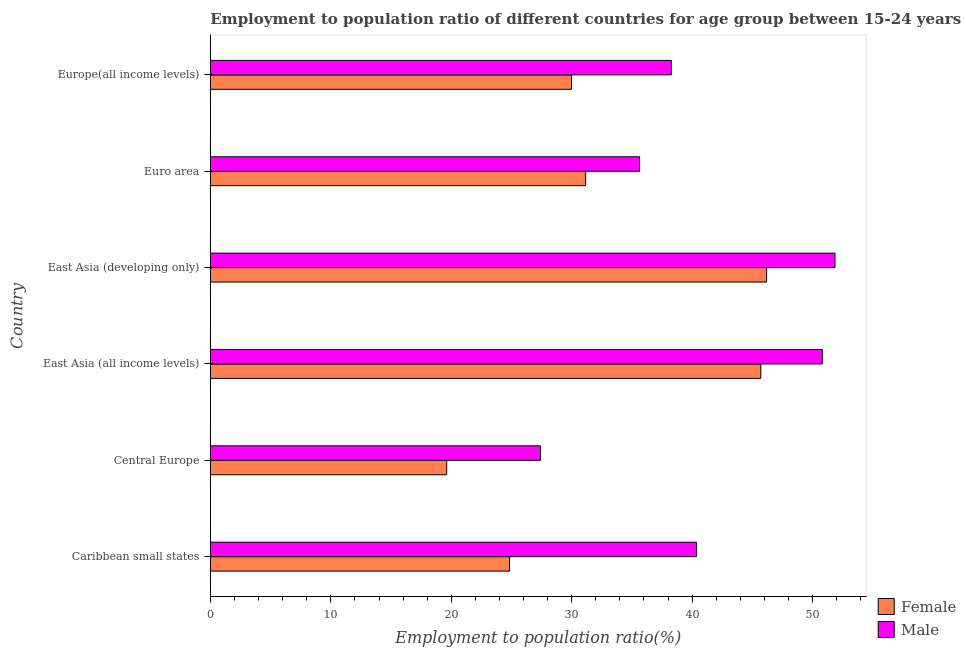How many bars are there on the 2nd tick from the top?
Provide a succinct answer. 2. What is the label of the 4th group of bars from the top?
Provide a short and direct response. East Asia (all income levels). What is the employment to population ratio(male) in Caribbean small states?
Provide a short and direct response. 40.37. Across all countries, what is the maximum employment to population ratio(male)?
Keep it short and to the point. 51.87. Across all countries, what is the minimum employment to population ratio(male)?
Offer a terse response. 27.41. In which country was the employment to population ratio(female) maximum?
Your response must be concise. East Asia (developing only). In which country was the employment to population ratio(male) minimum?
Ensure brevity in your answer.  Central Europe. What is the total employment to population ratio(male) in the graph?
Your response must be concise. 244.37. What is the difference between the employment to population ratio(male) in Central Europe and that in East Asia (developing only)?
Provide a succinct answer. -24.46. What is the difference between the employment to population ratio(male) in Euro area and the employment to population ratio(female) in East Asia (developing only)?
Ensure brevity in your answer.  -10.55. What is the average employment to population ratio(female) per country?
Your answer should be compact. 32.91. What is the difference between the employment to population ratio(male) and employment to population ratio(female) in Europe(all income levels)?
Offer a terse response. 8.29. In how many countries, is the employment to population ratio(male) greater than 20 %?
Ensure brevity in your answer.  6. What is the ratio of the employment to population ratio(male) in Central Europe to that in Europe(all income levels)?
Your answer should be compact. 0.72. What is the difference between the highest and the second highest employment to population ratio(female)?
Offer a terse response. 0.48. What is the difference between the highest and the lowest employment to population ratio(male)?
Give a very brief answer. 24.46. Is the sum of the employment to population ratio(female) in East Asia (all income levels) and Euro area greater than the maximum employment to population ratio(male) across all countries?
Provide a succinct answer. Yes. How many countries are there in the graph?
Provide a short and direct response. 6. Are the values on the major ticks of X-axis written in scientific E-notation?
Your answer should be very brief. No. Does the graph contain any zero values?
Make the answer very short. No. Does the graph contain grids?
Your answer should be very brief. No. Where does the legend appear in the graph?
Give a very brief answer. Bottom right. How are the legend labels stacked?
Your answer should be very brief. Vertical. What is the title of the graph?
Your answer should be very brief. Employment to population ratio of different countries for age group between 15-24 years. Does "GDP at market prices" appear as one of the legend labels in the graph?
Your answer should be compact. No. What is the Employment to population ratio(%) in Female in Caribbean small states?
Your answer should be very brief. 24.84. What is the Employment to population ratio(%) of Male in Caribbean small states?
Your answer should be very brief. 40.37. What is the Employment to population ratio(%) in Female in Central Europe?
Provide a short and direct response. 19.62. What is the Employment to population ratio(%) of Male in Central Europe?
Your answer should be compact. 27.41. What is the Employment to population ratio(%) of Female in East Asia (all income levels)?
Offer a terse response. 45.71. What is the Employment to population ratio(%) of Male in East Asia (all income levels)?
Offer a terse response. 50.81. What is the Employment to population ratio(%) of Female in East Asia (developing only)?
Ensure brevity in your answer.  46.19. What is the Employment to population ratio(%) of Male in East Asia (developing only)?
Give a very brief answer. 51.87. What is the Employment to population ratio(%) of Female in Euro area?
Provide a short and direct response. 31.16. What is the Employment to population ratio(%) of Male in Euro area?
Provide a succinct answer. 35.64. What is the Employment to population ratio(%) in Female in Europe(all income levels)?
Keep it short and to the point. 29.98. What is the Employment to population ratio(%) of Male in Europe(all income levels)?
Offer a very short reply. 38.28. Across all countries, what is the maximum Employment to population ratio(%) in Female?
Ensure brevity in your answer.  46.19. Across all countries, what is the maximum Employment to population ratio(%) of Male?
Make the answer very short. 51.87. Across all countries, what is the minimum Employment to population ratio(%) of Female?
Your response must be concise. 19.62. Across all countries, what is the minimum Employment to population ratio(%) of Male?
Offer a very short reply. 27.41. What is the total Employment to population ratio(%) of Female in the graph?
Keep it short and to the point. 197.49. What is the total Employment to population ratio(%) of Male in the graph?
Offer a very short reply. 244.37. What is the difference between the Employment to population ratio(%) of Female in Caribbean small states and that in Central Europe?
Offer a terse response. 5.22. What is the difference between the Employment to population ratio(%) in Male in Caribbean small states and that in Central Europe?
Offer a very short reply. 12.97. What is the difference between the Employment to population ratio(%) in Female in Caribbean small states and that in East Asia (all income levels)?
Your response must be concise. -20.87. What is the difference between the Employment to population ratio(%) of Male in Caribbean small states and that in East Asia (all income levels)?
Offer a terse response. -10.44. What is the difference between the Employment to population ratio(%) in Female in Caribbean small states and that in East Asia (developing only)?
Keep it short and to the point. -21.35. What is the difference between the Employment to population ratio(%) in Male in Caribbean small states and that in East Asia (developing only)?
Ensure brevity in your answer.  -11.49. What is the difference between the Employment to population ratio(%) of Female in Caribbean small states and that in Euro area?
Your response must be concise. -6.32. What is the difference between the Employment to population ratio(%) in Male in Caribbean small states and that in Euro area?
Make the answer very short. 4.74. What is the difference between the Employment to population ratio(%) of Female in Caribbean small states and that in Europe(all income levels)?
Your answer should be very brief. -5.15. What is the difference between the Employment to population ratio(%) in Male in Caribbean small states and that in Europe(all income levels)?
Provide a succinct answer. 2.1. What is the difference between the Employment to population ratio(%) of Female in Central Europe and that in East Asia (all income levels)?
Keep it short and to the point. -26.09. What is the difference between the Employment to population ratio(%) of Male in Central Europe and that in East Asia (all income levels)?
Give a very brief answer. -23.41. What is the difference between the Employment to population ratio(%) of Female in Central Europe and that in East Asia (developing only)?
Offer a very short reply. -26.57. What is the difference between the Employment to population ratio(%) of Male in Central Europe and that in East Asia (developing only)?
Your answer should be compact. -24.46. What is the difference between the Employment to population ratio(%) in Female in Central Europe and that in Euro area?
Provide a succinct answer. -11.54. What is the difference between the Employment to population ratio(%) of Male in Central Europe and that in Euro area?
Give a very brief answer. -8.23. What is the difference between the Employment to population ratio(%) of Female in Central Europe and that in Europe(all income levels)?
Your answer should be very brief. -10.36. What is the difference between the Employment to population ratio(%) in Male in Central Europe and that in Europe(all income levels)?
Your response must be concise. -10.87. What is the difference between the Employment to population ratio(%) in Female in East Asia (all income levels) and that in East Asia (developing only)?
Offer a terse response. -0.48. What is the difference between the Employment to population ratio(%) in Male in East Asia (all income levels) and that in East Asia (developing only)?
Ensure brevity in your answer.  -1.06. What is the difference between the Employment to population ratio(%) in Female in East Asia (all income levels) and that in Euro area?
Make the answer very short. 14.55. What is the difference between the Employment to population ratio(%) of Male in East Asia (all income levels) and that in Euro area?
Your response must be concise. 15.17. What is the difference between the Employment to population ratio(%) of Female in East Asia (all income levels) and that in Europe(all income levels)?
Your response must be concise. 15.73. What is the difference between the Employment to population ratio(%) in Male in East Asia (all income levels) and that in Europe(all income levels)?
Your answer should be very brief. 12.53. What is the difference between the Employment to population ratio(%) of Female in East Asia (developing only) and that in Euro area?
Your answer should be very brief. 15.03. What is the difference between the Employment to population ratio(%) of Male in East Asia (developing only) and that in Euro area?
Your answer should be compact. 16.23. What is the difference between the Employment to population ratio(%) in Female in East Asia (developing only) and that in Europe(all income levels)?
Provide a succinct answer. 16.2. What is the difference between the Employment to population ratio(%) in Male in East Asia (developing only) and that in Europe(all income levels)?
Your answer should be compact. 13.59. What is the difference between the Employment to population ratio(%) of Female in Euro area and that in Europe(all income levels)?
Provide a short and direct response. 1.17. What is the difference between the Employment to population ratio(%) in Male in Euro area and that in Europe(all income levels)?
Offer a very short reply. -2.64. What is the difference between the Employment to population ratio(%) of Female in Caribbean small states and the Employment to population ratio(%) of Male in Central Europe?
Your answer should be compact. -2.57. What is the difference between the Employment to population ratio(%) in Female in Caribbean small states and the Employment to population ratio(%) in Male in East Asia (all income levels)?
Ensure brevity in your answer.  -25.97. What is the difference between the Employment to population ratio(%) of Female in Caribbean small states and the Employment to population ratio(%) of Male in East Asia (developing only)?
Your answer should be compact. -27.03. What is the difference between the Employment to population ratio(%) in Female in Caribbean small states and the Employment to population ratio(%) in Male in Euro area?
Ensure brevity in your answer.  -10.8. What is the difference between the Employment to population ratio(%) in Female in Caribbean small states and the Employment to population ratio(%) in Male in Europe(all income levels)?
Provide a succinct answer. -13.44. What is the difference between the Employment to population ratio(%) in Female in Central Europe and the Employment to population ratio(%) in Male in East Asia (all income levels)?
Your answer should be compact. -31.19. What is the difference between the Employment to population ratio(%) in Female in Central Europe and the Employment to population ratio(%) in Male in East Asia (developing only)?
Offer a very short reply. -32.25. What is the difference between the Employment to population ratio(%) in Female in Central Europe and the Employment to population ratio(%) in Male in Euro area?
Your answer should be compact. -16.02. What is the difference between the Employment to population ratio(%) in Female in Central Europe and the Employment to population ratio(%) in Male in Europe(all income levels)?
Give a very brief answer. -18.66. What is the difference between the Employment to population ratio(%) in Female in East Asia (all income levels) and the Employment to population ratio(%) in Male in East Asia (developing only)?
Your answer should be very brief. -6.16. What is the difference between the Employment to population ratio(%) in Female in East Asia (all income levels) and the Employment to population ratio(%) in Male in Euro area?
Give a very brief answer. 10.07. What is the difference between the Employment to population ratio(%) in Female in East Asia (all income levels) and the Employment to population ratio(%) in Male in Europe(all income levels)?
Your response must be concise. 7.43. What is the difference between the Employment to population ratio(%) in Female in East Asia (developing only) and the Employment to population ratio(%) in Male in Euro area?
Your response must be concise. 10.55. What is the difference between the Employment to population ratio(%) of Female in East Asia (developing only) and the Employment to population ratio(%) of Male in Europe(all income levels)?
Offer a very short reply. 7.91. What is the difference between the Employment to population ratio(%) in Female in Euro area and the Employment to population ratio(%) in Male in Europe(all income levels)?
Your answer should be compact. -7.12. What is the average Employment to population ratio(%) in Female per country?
Provide a short and direct response. 32.92. What is the average Employment to population ratio(%) of Male per country?
Offer a very short reply. 40.73. What is the difference between the Employment to population ratio(%) in Female and Employment to population ratio(%) in Male in Caribbean small states?
Provide a succinct answer. -15.54. What is the difference between the Employment to population ratio(%) of Female and Employment to population ratio(%) of Male in Central Europe?
Provide a succinct answer. -7.79. What is the difference between the Employment to population ratio(%) in Female and Employment to population ratio(%) in Male in East Asia (all income levels)?
Make the answer very short. -5.1. What is the difference between the Employment to population ratio(%) of Female and Employment to population ratio(%) of Male in East Asia (developing only)?
Provide a succinct answer. -5.68. What is the difference between the Employment to population ratio(%) of Female and Employment to population ratio(%) of Male in Euro area?
Offer a terse response. -4.48. What is the difference between the Employment to population ratio(%) in Female and Employment to population ratio(%) in Male in Europe(all income levels)?
Your answer should be compact. -8.3. What is the ratio of the Employment to population ratio(%) in Female in Caribbean small states to that in Central Europe?
Your response must be concise. 1.27. What is the ratio of the Employment to population ratio(%) in Male in Caribbean small states to that in Central Europe?
Provide a short and direct response. 1.47. What is the ratio of the Employment to population ratio(%) of Female in Caribbean small states to that in East Asia (all income levels)?
Offer a terse response. 0.54. What is the ratio of the Employment to population ratio(%) in Male in Caribbean small states to that in East Asia (all income levels)?
Offer a terse response. 0.79. What is the ratio of the Employment to population ratio(%) of Female in Caribbean small states to that in East Asia (developing only)?
Ensure brevity in your answer.  0.54. What is the ratio of the Employment to population ratio(%) in Male in Caribbean small states to that in East Asia (developing only)?
Your response must be concise. 0.78. What is the ratio of the Employment to population ratio(%) of Female in Caribbean small states to that in Euro area?
Keep it short and to the point. 0.8. What is the ratio of the Employment to population ratio(%) in Male in Caribbean small states to that in Euro area?
Ensure brevity in your answer.  1.13. What is the ratio of the Employment to population ratio(%) in Female in Caribbean small states to that in Europe(all income levels)?
Your answer should be very brief. 0.83. What is the ratio of the Employment to population ratio(%) in Male in Caribbean small states to that in Europe(all income levels)?
Ensure brevity in your answer.  1.05. What is the ratio of the Employment to population ratio(%) in Female in Central Europe to that in East Asia (all income levels)?
Provide a short and direct response. 0.43. What is the ratio of the Employment to population ratio(%) of Male in Central Europe to that in East Asia (all income levels)?
Ensure brevity in your answer.  0.54. What is the ratio of the Employment to population ratio(%) in Female in Central Europe to that in East Asia (developing only)?
Give a very brief answer. 0.42. What is the ratio of the Employment to population ratio(%) in Male in Central Europe to that in East Asia (developing only)?
Your answer should be compact. 0.53. What is the ratio of the Employment to population ratio(%) of Female in Central Europe to that in Euro area?
Your answer should be very brief. 0.63. What is the ratio of the Employment to population ratio(%) of Male in Central Europe to that in Euro area?
Ensure brevity in your answer.  0.77. What is the ratio of the Employment to population ratio(%) of Female in Central Europe to that in Europe(all income levels)?
Offer a very short reply. 0.65. What is the ratio of the Employment to population ratio(%) of Male in Central Europe to that in Europe(all income levels)?
Your answer should be compact. 0.72. What is the ratio of the Employment to population ratio(%) in Male in East Asia (all income levels) to that in East Asia (developing only)?
Keep it short and to the point. 0.98. What is the ratio of the Employment to population ratio(%) in Female in East Asia (all income levels) to that in Euro area?
Your response must be concise. 1.47. What is the ratio of the Employment to population ratio(%) in Male in East Asia (all income levels) to that in Euro area?
Offer a very short reply. 1.43. What is the ratio of the Employment to population ratio(%) of Female in East Asia (all income levels) to that in Europe(all income levels)?
Provide a short and direct response. 1.52. What is the ratio of the Employment to population ratio(%) in Male in East Asia (all income levels) to that in Europe(all income levels)?
Offer a terse response. 1.33. What is the ratio of the Employment to population ratio(%) in Female in East Asia (developing only) to that in Euro area?
Provide a short and direct response. 1.48. What is the ratio of the Employment to population ratio(%) of Male in East Asia (developing only) to that in Euro area?
Your answer should be very brief. 1.46. What is the ratio of the Employment to population ratio(%) in Female in East Asia (developing only) to that in Europe(all income levels)?
Keep it short and to the point. 1.54. What is the ratio of the Employment to population ratio(%) in Male in East Asia (developing only) to that in Europe(all income levels)?
Provide a short and direct response. 1.35. What is the ratio of the Employment to population ratio(%) of Female in Euro area to that in Europe(all income levels)?
Your response must be concise. 1.04. What is the ratio of the Employment to population ratio(%) of Male in Euro area to that in Europe(all income levels)?
Your answer should be compact. 0.93. What is the difference between the highest and the second highest Employment to population ratio(%) of Female?
Your answer should be compact. 0.48. What is the difference between the highest and the second highest Employment to population ratio(%) of Male?
Your answer should be compact. 1.06. What is the difference between the highest and the lowest Employment to population ratio(%) of Female?
Keep it short and to the point. 26.57. What is the difference between the highest and the lowest Employment to population ratio(%) of Male?
Give a very brief answer. 24.46. 